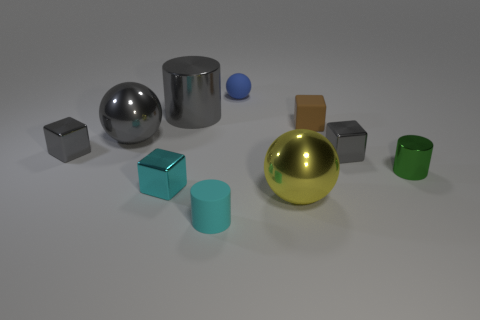How many things are yellow things that are to the right of the tiny matte cylinder or large gray things?
Your answer should be very brief. 3. How many other things are the same size as the green metal cylinder?
Provide a succinct answer. 6. There is a gray cube behind the gray block that is on the right side of the large shiny ball to the right of the blue ball; what is it made of?
Offer a terse response. Metal. How many cubes are either tiny gray metal things or brown matte things?
Provide a succinct answer. 3. Is there anything else that is the same shape as the small green object?
Your answer should be compact. Yes. Are there more cyan things in front of the yellow shiny object than green metallic objects left of the small brown block?
Make the answer very short. Yes. There is a small gray metallic object to the right of the tiny ball; what number of balls are in front of it?
Your response must be concise. 1. What number of things are small rubber things or tiny purple matte cylinders?
Offer a very short reply. 3. Is the cyan matte thing the same shape as the green metal thing?
Ensure brevity in your answer.  Yes. What is the material of the small blue object?
Keep it short and to the point. Rubber. 